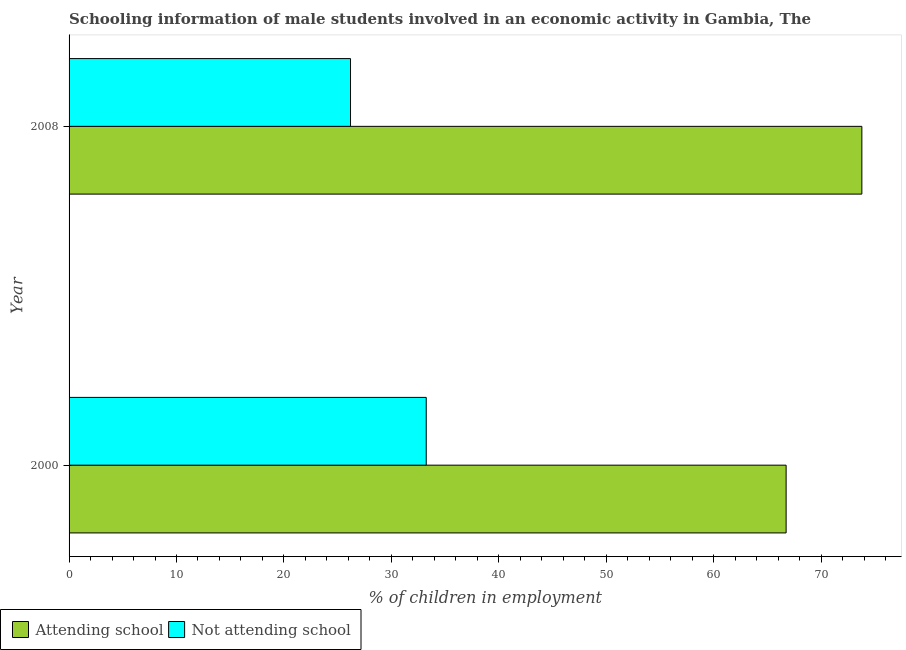How many different coloured bars are there?
Ensure brevity in your answer.  2. How many groups of bars are there?
Offer a very short reply. 2. Are the number of bars per tick equal to the number of legend labels?
Make the answer very short. Yes. Are the number of bars on each tick of the Y-axis equal?
Your answer should be very brief. Yes. How many bars are there on the 2nd tick from the top?
Your answer should be compact. 2. What is the label of the 1st group of bars from the top?
Give a very brief answer. 2008. In how many cases, is the number of bars for a given year not equal to the number of legend labels?
Offer a terse response. 0. What is the percentage of employed males who are not attending school in 2000?
Your response must be concise. 33.25. Across all years, what is the maximum percentage of employed males who are not attending school?
Give a very brief answer. 33.25. Across all years, what is the minimum percentage of employed males who are attending school?
Your answer should be very brief. 66.75. In which year was the percentage of employed males who are attending school maximum?
Your response must be concise. 2008. What is the total percentage of employed males who are not attending school in the graph?
Provide a succinct answer. 59.45. What is the difference between the percentage of employed males who are not attending school in 2000 and that in 2008?
Provide a succinct answer. 7.05. What is the difference between the percentage of employed males who are attending school in 2000 and the percentage of employed males who are not attending school in 2008?
Your response must be concise. 40.55. What is the average percentage of employed males who are not attending school per year?
Offer a terse response. 29.73. In the year 2000, what is the difference between the percentage of employed males who are not attending school and percentage of employed males who are attending school?
Give a very brief answer. -33.5. What is the ratio of the percentage of employed males who are not attending school in 2000 to that in 2008?
Ensure brevity in your answer.  1.27. Is the difference between the percentage of employed males who are not attending school in 2000 and 2008 greater than the difference between the percentage of employed males who are attending school in 2000 and 2008?
Keep it short and to the point. Yes. In how many years, is the percentage of employed males who are attending school greater than the average percentage of employed males who are attending school taken over all years?
Keep it short and to the point. 1. What does the 1st bar from the top in 2008 represents?
Keep it short and to the point. Not attending school. What does the 1st bar from the bottom in 2008 represents?
Provide a short and direct response. Attending school. How many bars are there?
Ensure brevity in your answer.  4. What is the difference between two consecutive major ticks on the X-axis?
Give a very brief answer. 10. Are the values on the major ticks of X-axis written in scientific E-notation?
Your answer should be very brief. No. Does the graph contain grids?
Your response must be concise. No. How many legend labels are there?
Give a very brief answer. 2. How are the legend labels stacked?
Your answer should be compact. Horizontal. What is the title of the graph?
Provide a succinct answer. Schooling information of male students involved in an economic activity in Gambia, The. What is the label or title of the X-axis?
Your response must be concise. % of children in employment. What is the label or title of the Y-axis?
Your answer should be very brief. Year. What is the % of children in employment of Attending school in 2000?
Provide a short and direct response. 66.75. What is the % of children in employment in Not attending school in 2000?
Keep it short and to the point. 33.25. What is the % of children in employment of Attending school in 2008?
Ensure brevity in your answer.  73.8. What is the % of children in employment in Not attending school in 2008?
Offer a very short reply. 26.2. Across all years, what is the maximum % of children in employment in Attending school?
Make the answer very short. 73.8. Across all years, what is the maximum % of children in employment of Not attending school?
Make the answer very short. 33.25. Across all years, what is the minimum % of children in employment in Attending school?
Make the answer very short. 66.75. Across all years, what is the minimum % of children in employment of Not attending school?
Ensure brevity in your answer.  26.2. What is the total % of children in employment in Attending school in the graph?
Give a very brief answer. 140.55. What is the total % of children in employment of Not attending school in the graph?
Give a very brief answer. 59.45. What is the difference between the % of children in employment of Attending school in 2000 and that in 2008?
Your answer should be very brief. -7.05. What is the difference between the % of children in employment of Not attending school in 2000 and that in 2008?
Offer a very short reply. 7.05. What is the difference between the % of children in employment in Attending school in 2000 and the % of children in employment in Not attending school in 2008?
Ensure brevity in your answer.  40.55. What is the average % of children in employment of Attending school per year?
Keep it short and to the point. 70.28. What is the average % of children in employment in Not attending school per year?
Your answer should be very brief. 29.72. In the year 2000, what is the difference between the % of children in employment of Attending school and % of children in employment of Not attending school?
Ensure brevity in your answer.  33.5. In the year 2008, what is the difference between the % of children in employment of Attending school and % of children in employment of Not attending school?
Offer a very short reply. 47.6. What is the ratio of the % of children in employment in Attending school in 2000 to that in 2008?
Provide a short and direct response. 0.9. What is the ratio of the % of children in employment of Not attending school in 2000 to that in 2008?
Give a very brief answer. 1.27. What is the difference between the highest and the second highest % of children in employment in Attending school?
Make the answer very short. 7.05. What is the difference between the highest and the second highest % of children in employment in Not attending school?
Make the answer very short. 7.05. What is the difference between the highest and the lowest % of children in employment in Attending school?
Offer a very short reply. 7.05. What is the difference between the highest and the lowest % of children in employment in Not attending school?
Ensure brevity in your answer.  7.05. 